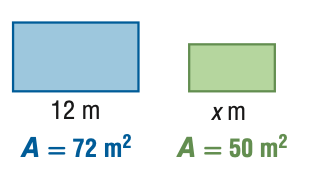Answer the mathemtical geometry problem and directly provide the correct option letter.
Question: For the pair of similar figures, use the given areas to find x.
Choices: A: 8.3 B: 10.0 C: 14.4 D: 17.3 B 